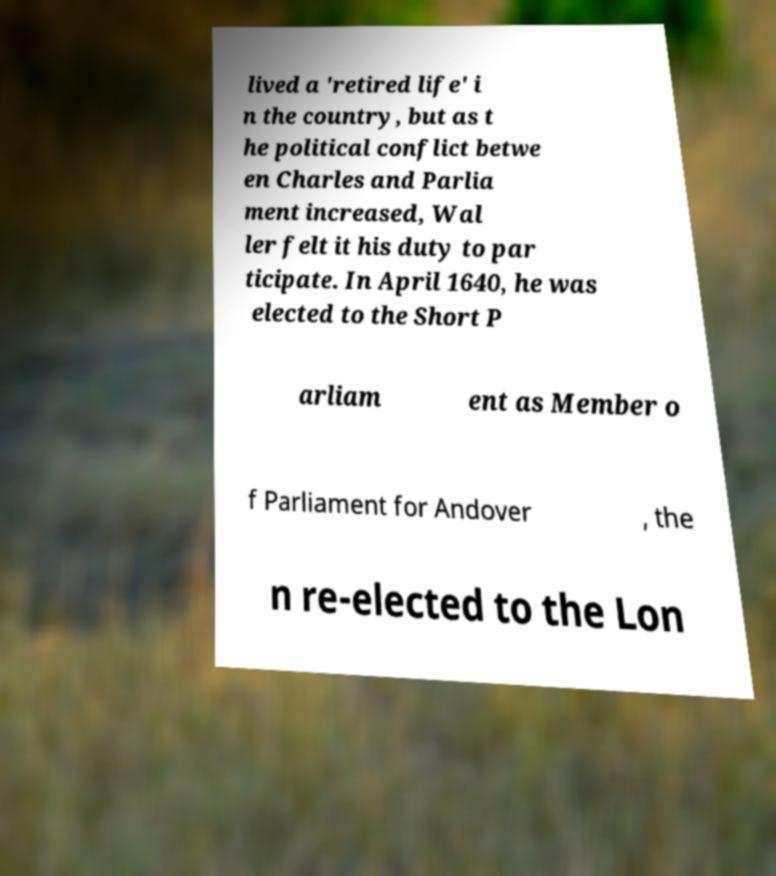Please read and relay the text visible in this image. What does it say? lived a 'retired life' i n the country, but as t he political conflict betwe en Charles and Parlia ment increased, Wal ler felt it his duty to par ticipate. In April 1640, he was elected to the Short P arliam ent as Member o f Parliament for Andover , the n re-elected to the Lon 